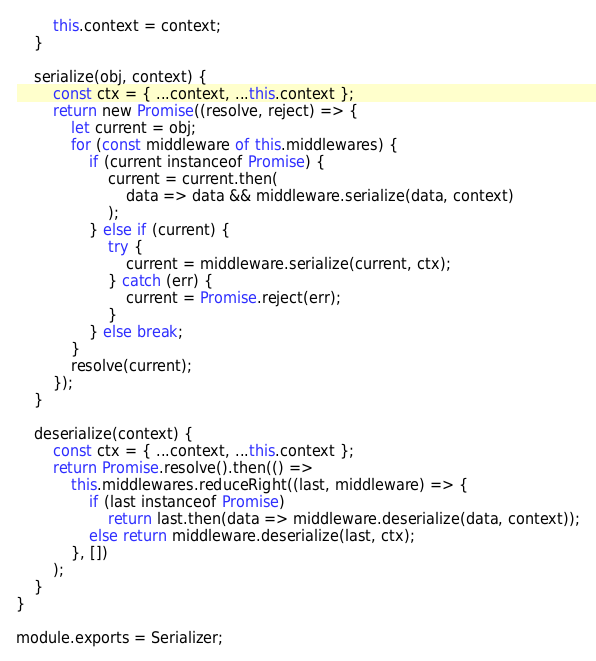<code> <loc_0><loc_0><loc_500><loc_500><_JavaScript_>		this.context = context;
	}

	serialize(obj, context) {
		const ctx = { ...context, ...this.context };
		return new Promise((resolve, reject) => {
			let current = obj;
			for (const middleware of this.middlewares) {
				if (current instanceof Promise) {
					current = current.then(
						data => data && middleware.serialize(data, context)
					);
				} else if (current) {
					try {
						current = middleware.serialize(current, ctx);
					} catch (err) {
						current = Promise.reject(err);
					}
				} else break;
			}
			resolve(current);
		});
	}

	deserialize(context) {
		const ctx = { ...context, ...this.context };
		return Promise.resolve().then(() =>
			this.middlewares.reduceRight((last, middleware) => {
				if (last instanceof Promise)
					return last.then(data => middleware.deserialize(data, context));
				else return middleware.deserialize(last, ctx);
			}, [])
		);
	}
}

module.exports = Serializer;
</code> 